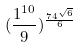Convert formula to latex. <formula><loc_0><loc_0><loc_500><loc_500>( \frac { 1 ^ { 1 0 } } { 9 } ) ^ { \frac { 7 4 ^ { \sqrt { 6 } } } { 6 } }</formula> 